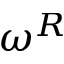<formula> <loc_0><loc_0><loc_500><loc_500>\omega ^ { R }</formula> 